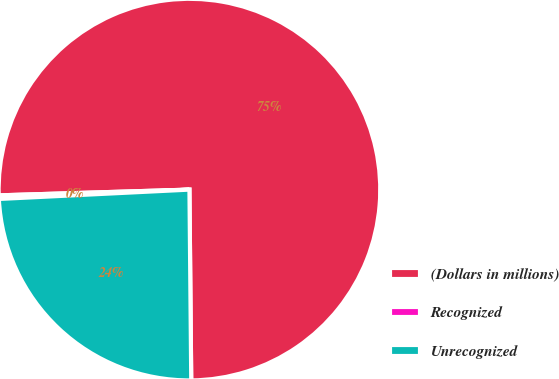Convert chart. <chart><loc_0><loc_0><loc_500><loc_500><pie_chart><fcel>(Dollars in millions)<fcel>Recognized<fcel>Unrecognized<nl><fcel>75.33%<fcel>0.3%<fcel>24.37%<nl></chart> 